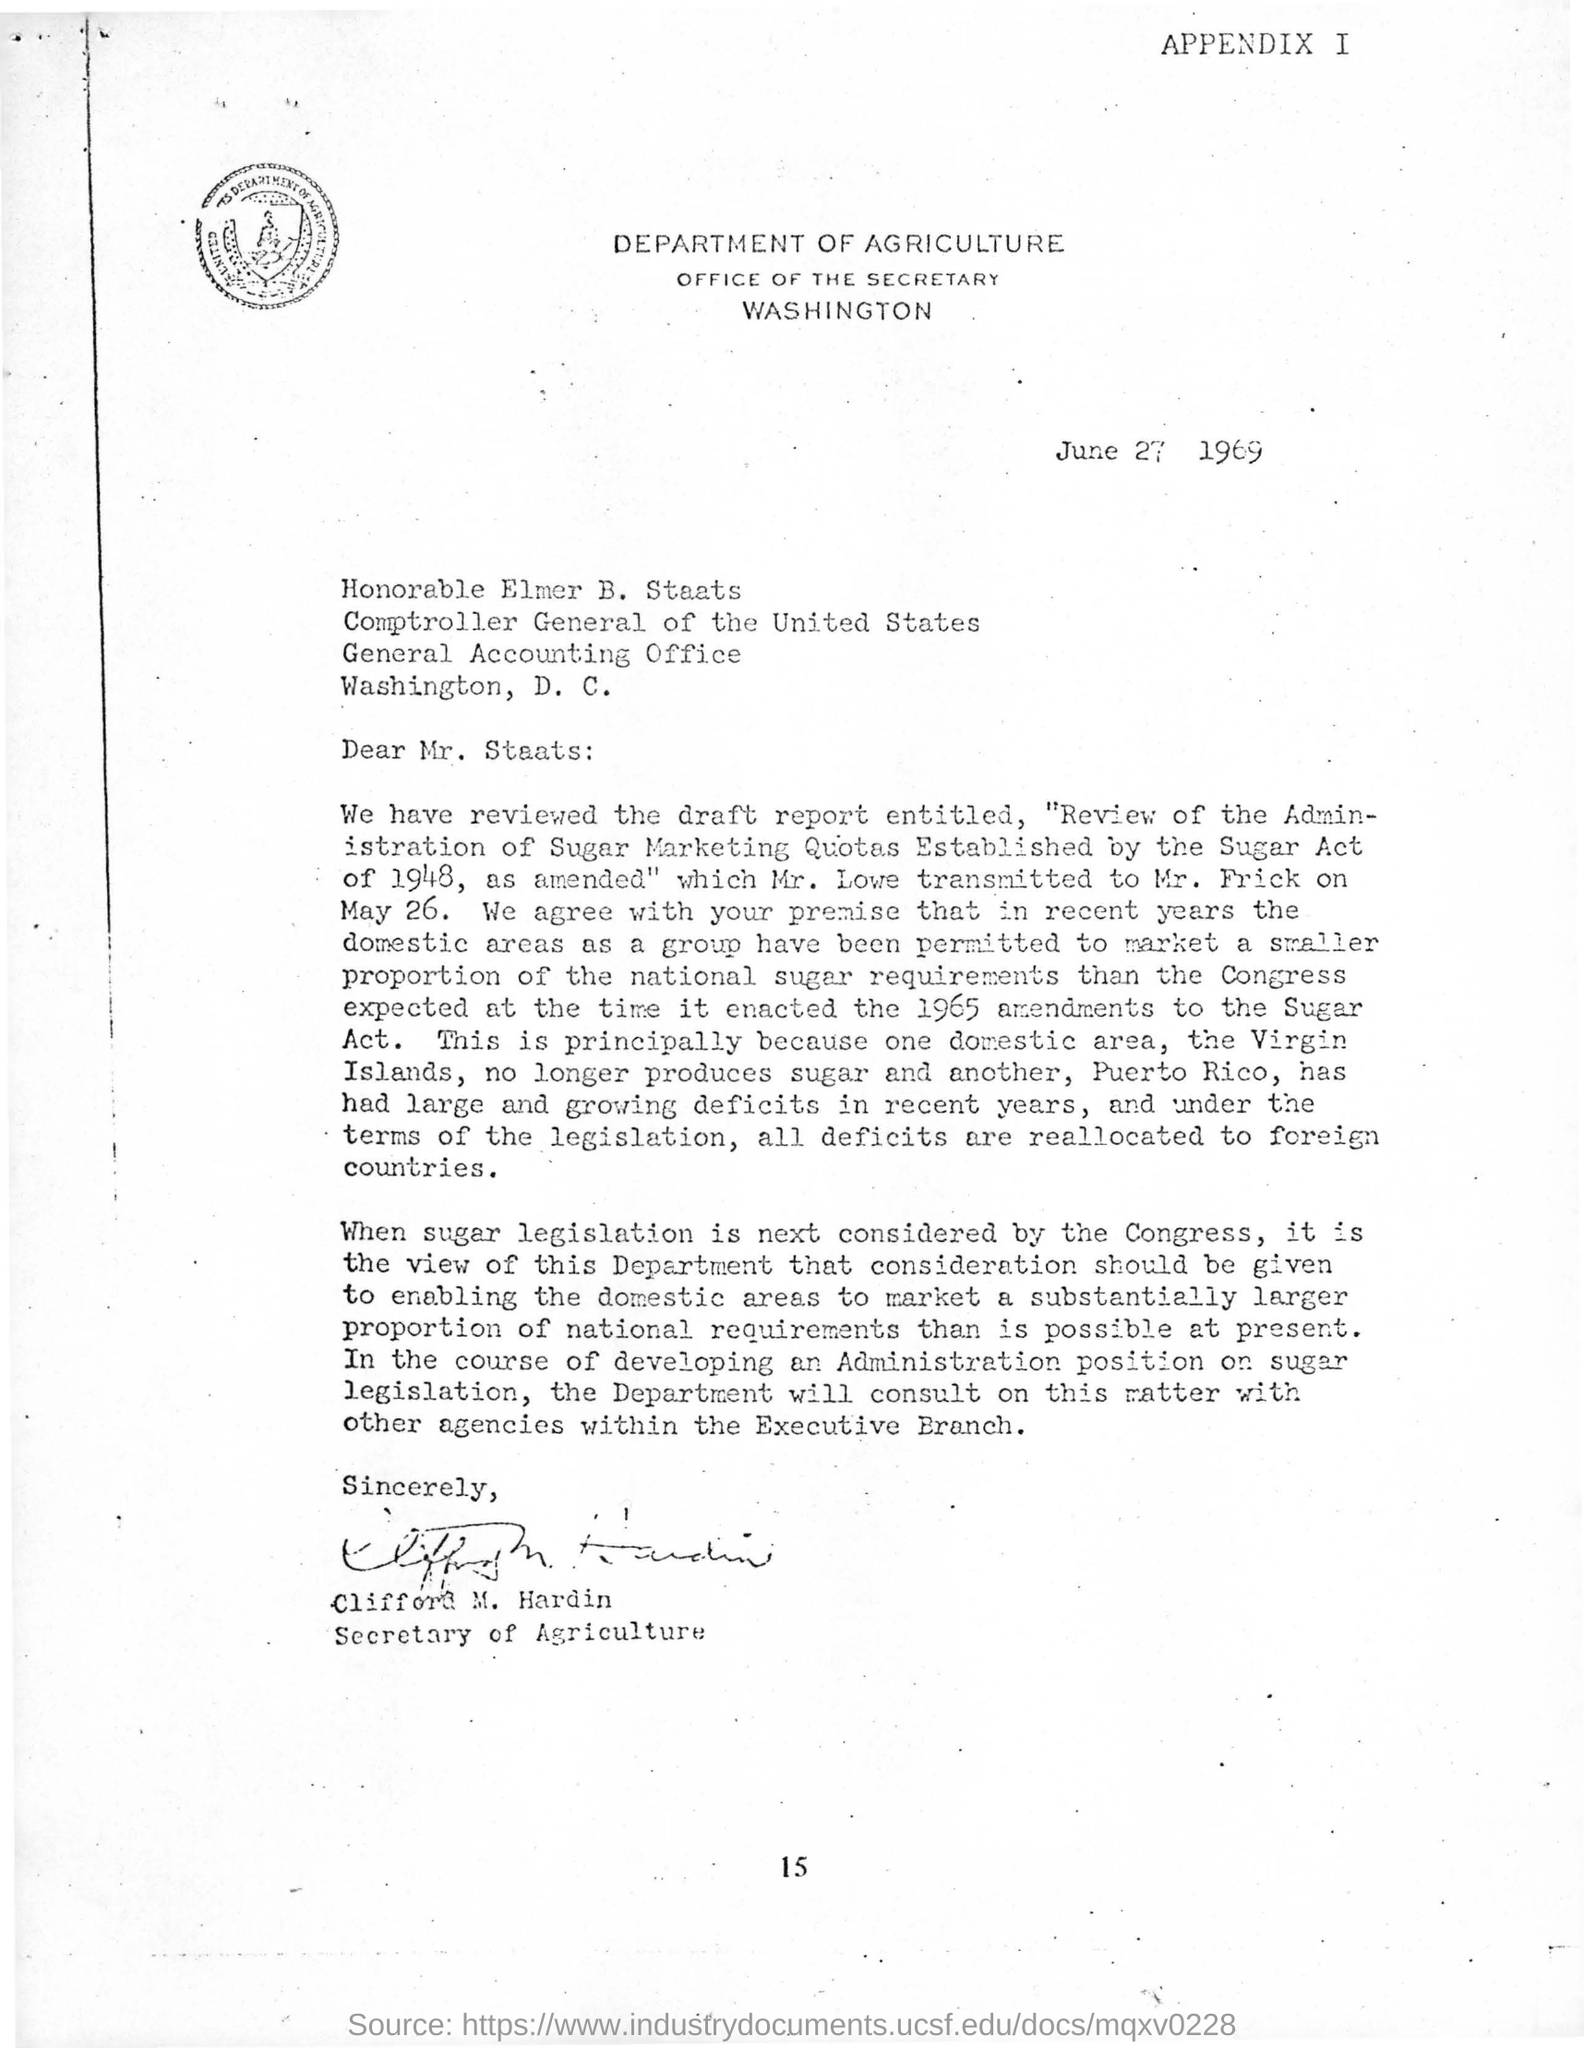Which department letter head is this
Offer a very short reply. Department of Agriculture. 